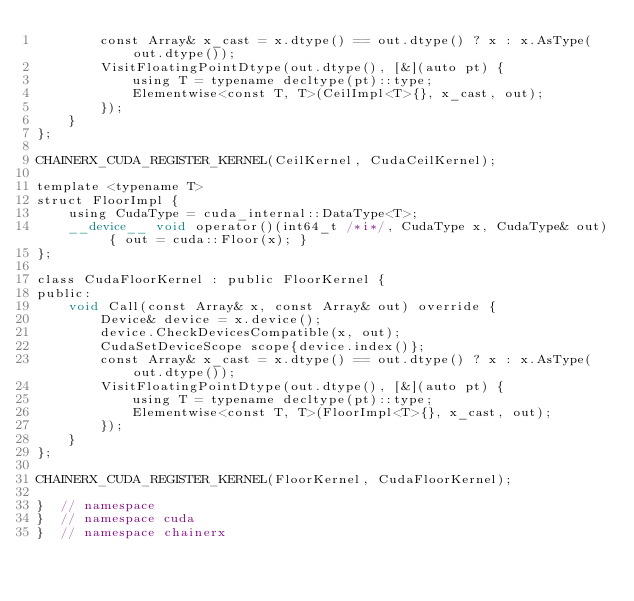<code> <loc_0><loc_0><loc_500><loc_500><_Cuda_>        const Array& x_cast = x.dtype() == out.dtype() ? x : x.AsType(out.dtype());
        VisitFloatingPointDtype(out.dtype(), [&](auto pt) {
            using T = typename decltype(pt)::type;
            Elementwise<const T, T>(CeilImpl<T>{}, x_cast, out);
        });
    }
};

CHAINERX_CUDA_REGISTER_KERNEL(CeilKernel, CudaCeilKernel);

template <typename T>
struct FloorImpl {
    using CudaType = cuda_internal::DataType<T>;
    __device__ void operator()(int64_t /*i*/, CudaType x, CudaType& out) { out = cuda::Floor(x); }
};

class CudaFloorKernel : public FloorKernel {
public:
    void Call(const Array& x, const Array& out) override {
        Device& device = x.device();
        device.CheckDevicesCompatible(x, out);
        CudaSetDeviceScope scope{device.index()};
        const Array& x_cast = x.dtype() == out.dtype() ? x : x.AsType(out.dtype());
        VisitFloatingPointDtype(out.dtype(), [&](auto pt) {
            using T = typename decltype(pt)::type;
            Elementwise<const T, T>(FloorImpl<T>{}, x_cast, out);
        });
    }
};

CHAINERX_CUDA_REGISTER_KERNEL(FloorKernel, CudaFloorKernel);

}  // namespace
}  // namespace cuda
}  // namespace chainerx
</code> 